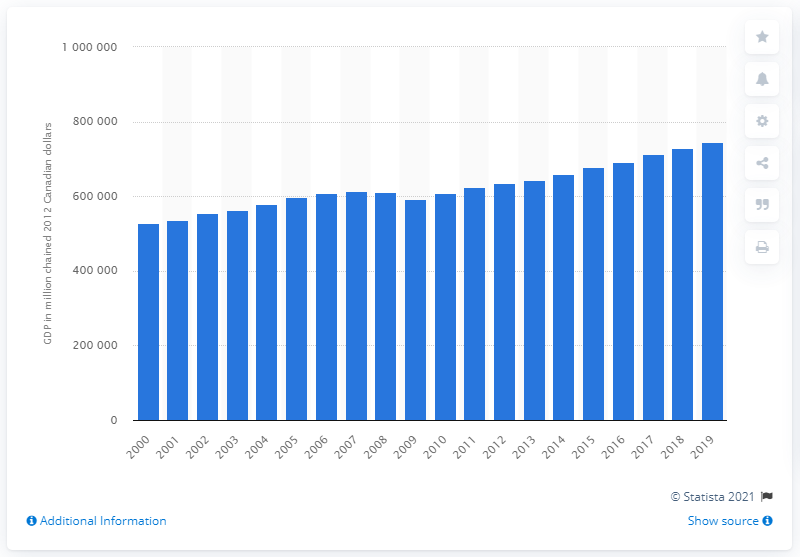List a handful of essential elements in this visual. In 2012, the Gross Domestic Product (GDP) of Ontario in Canadian dollars was 744,439.6. 